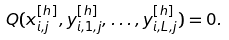<formula> <loc_0><loc_0><loc_500><loc_500>Q ( x _ { i , j } ^ { [ h ] } , y _ { i , 1 , j } ^ { [ h ] } , \dots , y _ { i , L , j } ^ { [ h ] } ) = 0 .</formula> 